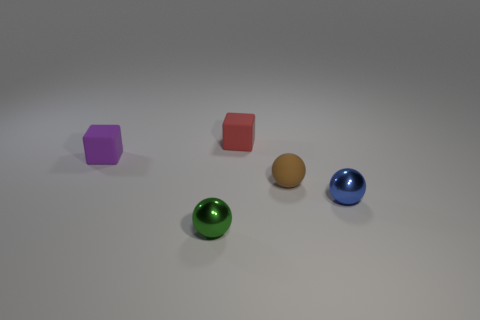Do the small green ball and the tiny red block have the same material?
Ensure brevity in your answer.  No. There is a metal ball that is right of the small brown object; is there a small ball that is in front of it?
Your response must be concise. Yes. What number of small rubber objects are both on the right side of the green metallic object and in front of the tiny red matte cube?
Provide a short and direct response. 1. There is a green object that is in front of the small purple matte cube; what shape is it?
Offer a terse response. Sphere. What number of balls are the same size as the red object?
Keep it short and to the point. 3. There is a small thing that is both on the left side of the matte ball and in front of the tiny purple rubber thing; what is its material?
Ensure brevity in your answer.  Metal. Is the number of small brown things greater than the number of blue rubber cubes?
Give a very brief answer. Yes. There is a tiny cube in front of the small block right of the shiny sphere left of the small blue ball; what is its color?
Provide a short and direct response. Purple. Is the material of the small object to the left of the small green object the same as the small blue object?
Give a very brief answer. No. Is there a matte object?
Give a very brief answer. Yes. 